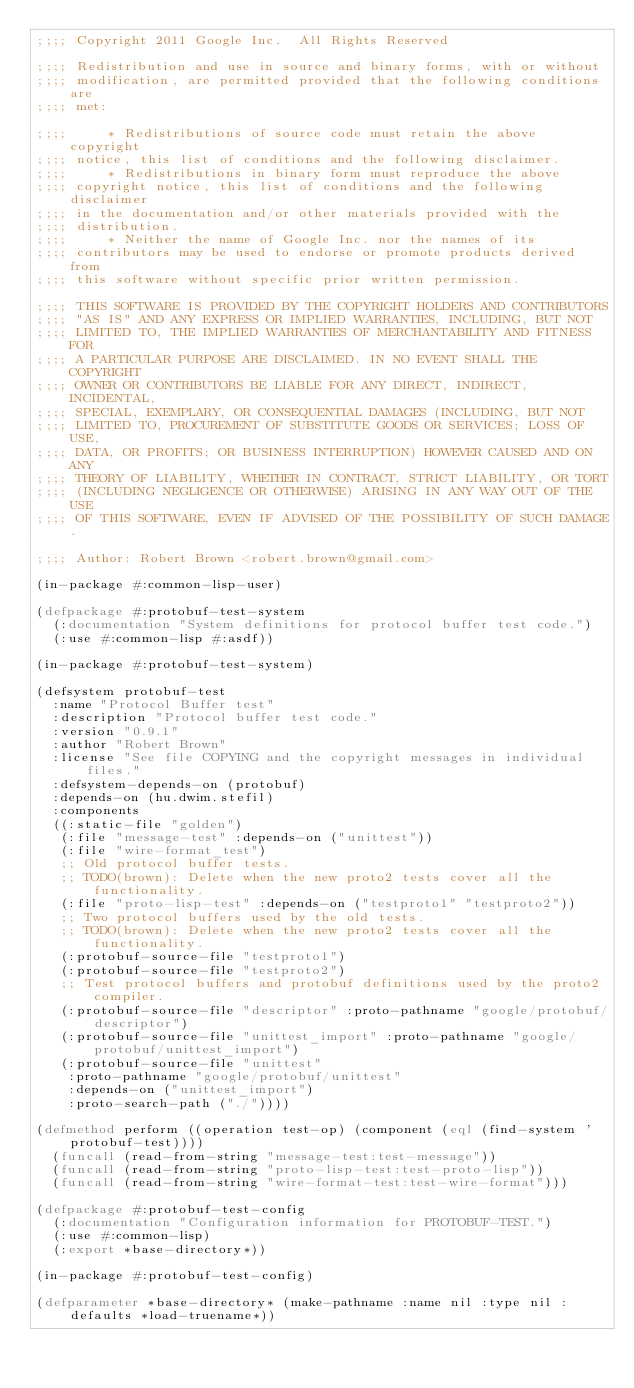Convert code to text. <code><loc_0><loc_0><loc_500><loc_500><_Lisp_>;;;; Copyright 2011 Google Inc.  All Rights Reserved

;;;; Redistribution and use in source and binary forms, with or without
;;;; modification, are permitted provided that the following conditions are
;;;; met:

;;;;     * Redistributions of source code must retain the above copyright
;;;; notice, this list of conditions and the following disclaimer.
;;;;     * Redistributions in binary form must reproduce the above
;;;; copyright notice, this list of conditions and the following disclaimer
;;;; in the documentation and/or other materials provided with the
;;;; distribution.
;;;;     * Neither the name of Google Inc. nor the names of its
;;;; contributors may be used to endorse or promote products derived from
;;;; this software without specific prior written permission.

;;;; THIS SOFTWARE IS PROVIDED BY THE COPYRIGHT HOLDERS AND CONTRIBUTORS
;;;; "AS IS" AND ANY EXPRESS OR IMPLIED WARRANTIES, INCLUDING, BUT NOT
;;;; LIMITED TO, THE IMPLIED WARRANTIES OF MERCHANTABILITY AND FITNESS FOR
;;;; A PARTICULAR PURPOSE ARE DISCLAIMED. IN NO EVENT SHALL THE COPYRIGHT
;;;; OWNER OR CONTRIBUTORS BE LIABLE FOR ANY DIRECT, INDIRECT, INCIDENTAL,
;;;; SPECIAL, EXEMPLARY, OR CONSEQUENTIAL DAMAGES (INCLUDING, BUT NOT
;;;; LIMITED TO, PROCUREMENT OF SUBSTITUTE GOODS OR SERVICES; LOSS OF USE,
;;;; DATA, OR PROFITS; OR BUSINESS INTERRUPTION) HOWEVER CAUSED AND ON ANY
;;;; THEORY OF LIABILITY, WHETHER IN CONTRACT, STRICT LIABILITY, OR TORT
;;;; (INCLUDING NEGLIGENCE OR OTHERWISE) ARISING IN ANY WAY OUT OF THE USE
;;;; OF THIS SOFTWARE, EVEN IF ADVISED OF THE POSSIBILITY OF SUCH DAMAGE.

;;;; Author: Robert Brown <robert.brown@gmail.com>

(in-package #:common-lisp-user)

(defpackage #:protobuf-test-system
  (:documentation "System definitions for protocol buffer test code.")
  (:use #:common-lisp #:asdf))

(in-package #:protobuf-test-system)

(defsystem protobuf-test
  :name "Protocol Buffer test"
  :description "Protocol buffer test code."
  :version "0.9.1"
  :author "Robert Brown"
  :license "See file COPYING and the copyright messages in individual files."
  :defsystem-depends-on (protobuf)
  :depends-on (hu.dwim.stefil)
  :components
  ((:static-file "golden")
   (:file "message-test" :depends-on ("unittest"))
   (:file "wire-format_test")
   ;; Old protocol buffer tests.
   ;; TODO(brown): Delete when the new proto2 tests cover all the functionality.
   (:file "proto-lisp-test" :depends-on ("testproto1" "testproto2"))
   ;; Two protocol buffers used by the old tests.
   ;; TODO(brown): Delete when the new proto2 tests cover all the functionality.
   (:protobuf-source-file "testproto1")
   (:protobuf-source-file "testproto2")
   ;; Test protocol buffers and protobuf definitions used by the proto2 compiler.
   (:protobuf-source-file "descriptor" :proto-pathname "google/protobuf/descriptor")
   (:protobuf-source-file "unittest_import" :proto-pathname "google/protobuf/unittest_import")
   (:protobuf-source-file "unittest"
    :proto-pathname "google/protobuf/unittest"
    :depends-on ("unittest_import")
    :proto-search-path ("./"))))

(defmethod perform ((operation test-op) (component (eql (find-system 'protobuf-test))))
  (funcall (read-from-string "message-test:test-message"))
  (funcall (read-from-string "proto-lisp-test:test-proto-lisp"))
  (funcall (read-from-string "wire-format-test:test-wire-format")))

(defpackage #:protobuf-test-config
  (:documentation "Configuration information for PROTOBUF-TEST.")
  (:use #:common-lisp)
  (:export *base-directory*))

(in-package #:protobuf-test-config)

(defparameter *base-directory* (make-pathname :name nil :type nil :defaults *load-truename*))
</code> 